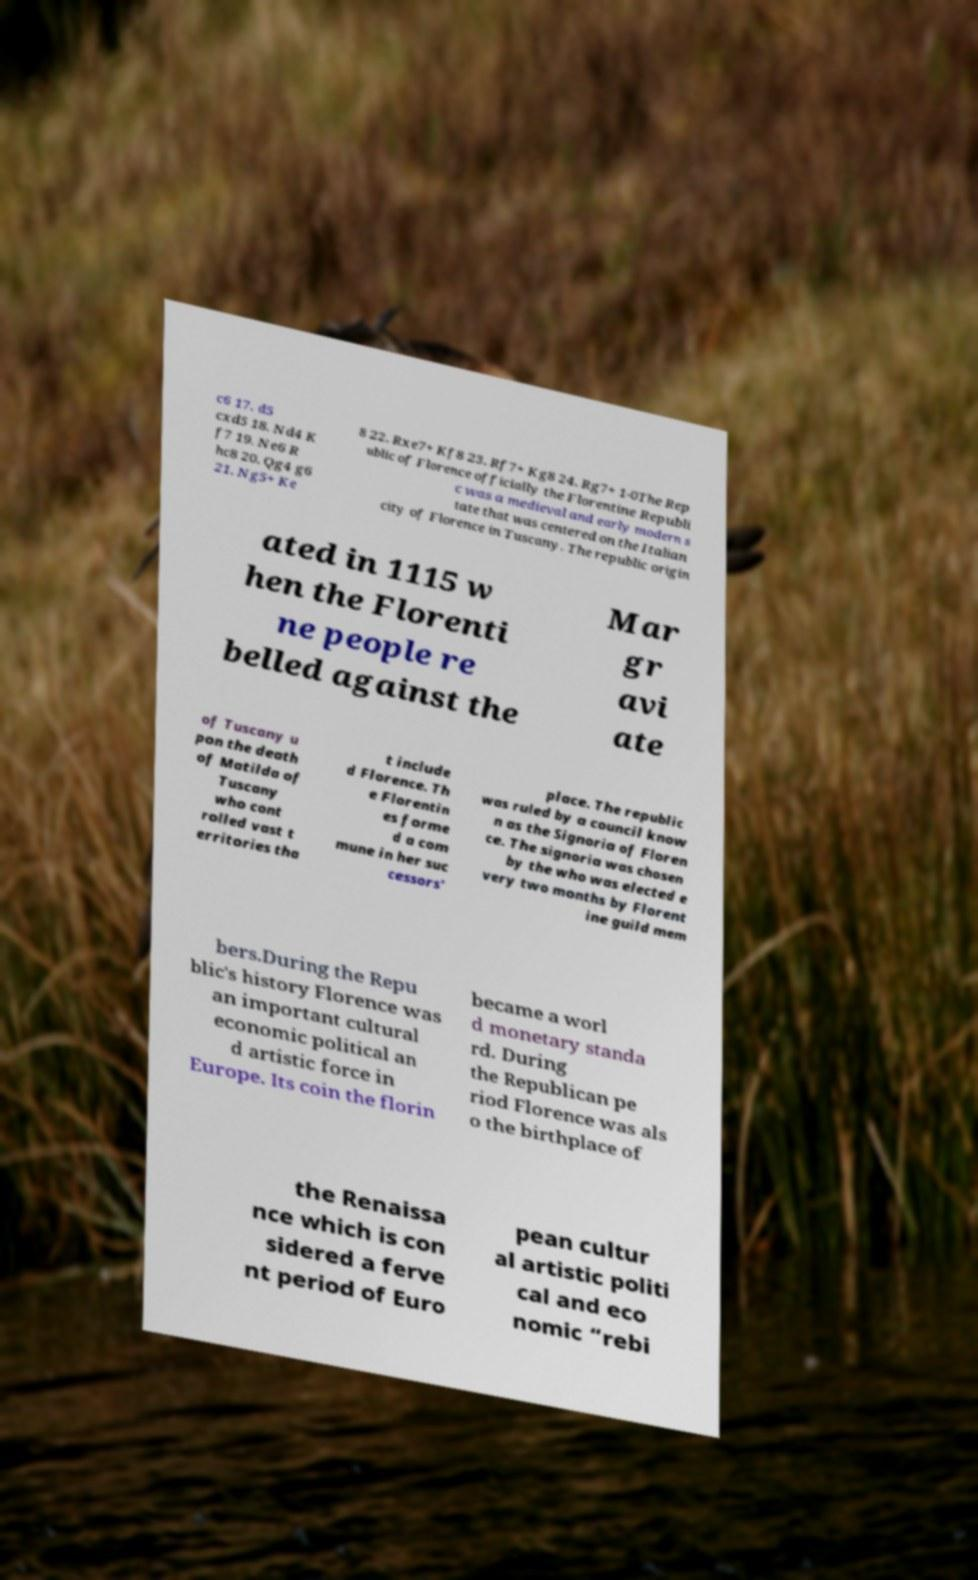Can you read and provide the text displayed in the image?This photo seems to have some interesting text. Can you extract and type it out for me? c6 17. d5 cxd5 18. Nd4 K f7 19. Ne6 R hc8 20. Qg4 g6 21. Ng5+ Ke 8 22. Rxe7+ Kf8 23. Rf7+ Kg8 24. Rg7+ 1-0The Rep ublic of Florence officially the Florentine Republi c was a medieval and early modern s tate that was centered on the Italian city of Florence in Tuscany. The republic origin ated in 1115 w hen the Florenti ne people re belled against the Mar gr avi ate of Tuscany u pon the death of Matilda of Tuscany who cont rolled vast t erritories tha t include d Florence. Th e Florentin es forme d a com mune in her suc cessors' place. The republic was ruled by a council know n as the Signoria of Floren ce. The signoria was chosen by the who was elected e very two months by Florent ine guild mem bers.During the Repu blic's history Florence was an important cultural economic political an d artistic force in Europe. Its coin the florin became a worl d monetary standa rd. During the Republican pe riod Florence was als o the birthplace of the Renaissa nce which is con sidered a ferve nt period of Euro pean cultur al artistic politi cal and eco nomic “rebi 